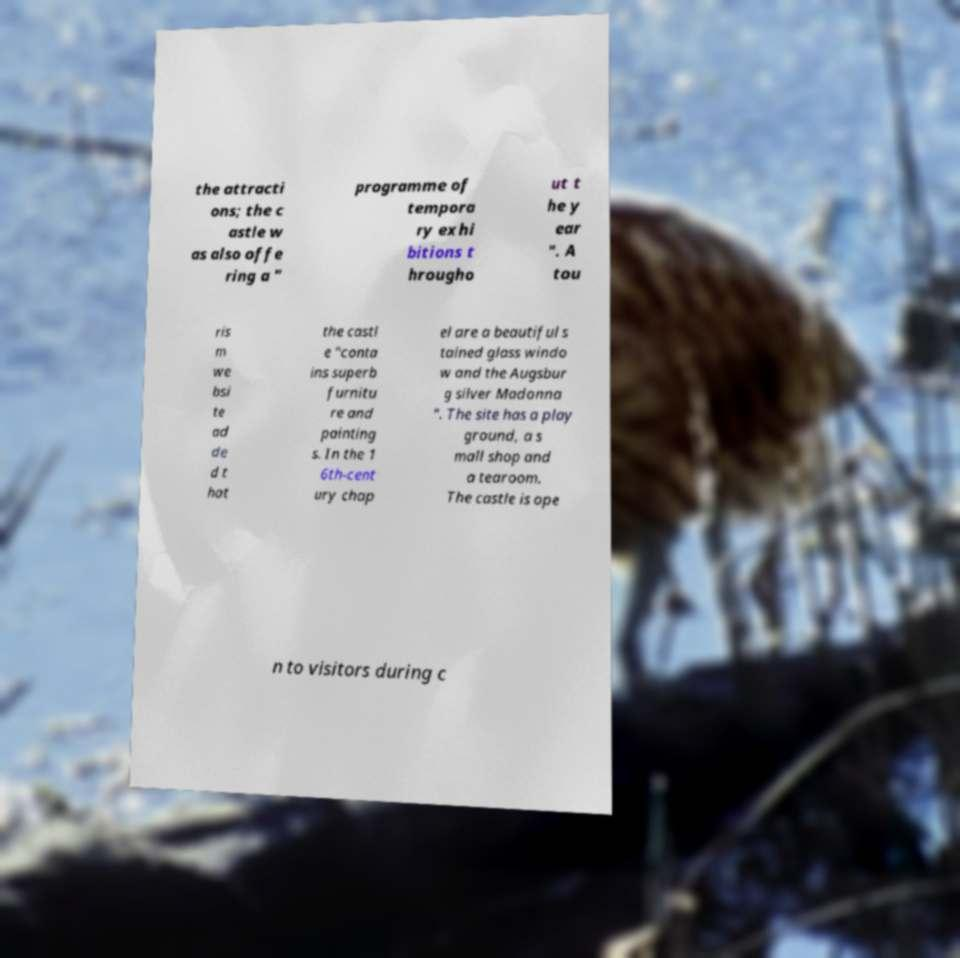Could you extract and type out the text from this image? the attracti ons; the c astle w as also offe ring a " programme of tempora ry exhi bitions t hrougho ut t he y ear ". A tou ris m we bsi te ad de d t hat the castl e "conta ins superb furnitu re and painting s. In the 1 6th-cent ury chap el are a beautiful s tained glass windo w and the Augsbur g silver Madonna ". The site has a play ground, a s mall shop and a tearoom. The castle is ope n to visitors during c 